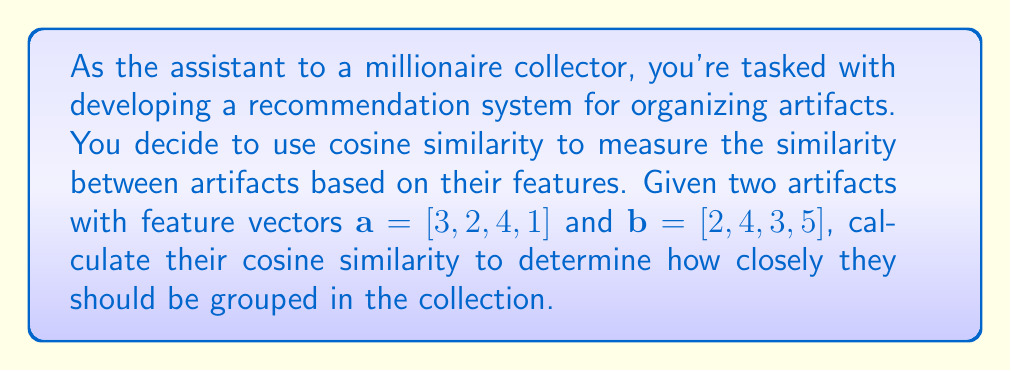Could you help me with this problem? To calculate the cosine similarity between two vectors $\mathbf{a}$ and $\mathbf{b}$, we use the formula:

$$\text{cosine similarity} = \frac{\mathbf{a} \cdot \mathbf{b}}{\|\mathbf{a}\| \|\mathbf{b}\|}$$

Where $\mathbf{a} \cdot \mathbf{b}$ is the dot product of the vectors, and $\|\mathbf{a}\|$ and $\|\mathbf{b}\|$ are the magnitudes (Euclidean norms) of the vectors.

Step 1: Calculate the dot product $\mathbf{a} \cdot \mathbf{b}$
$$\mathbf{a} \cdot \mathbf{b} = (3 \times 2) + (2 \times 4) + (4 \times 3) + (1 \times 5) = 6 + 8 + 12 + 5 = 31$$

Step 2: Calculate the magnitude of $\mathbf{a}$
$$\|\mathbf{a}\| = \sqrt{3^2 + 2^2 + 4^2 + 1^2} = \sqrt{9 + 4 + 16 + 1} = \sqrt{30}$$

Step 3: Calculate the magnitude of $\mathbf{b}$
$$\|\mathbf{b}\| = \sqrt{2^2 + 4^2 + 3^2 + 5^2} = \sqrt{4 + 16 + 9 + 25} = \sqrt{54}$$

Step 4: Apply the cosine similarity formula
$$\text{cosine similarity} = \frac{31}{\sqrt{30} \times \sqrt{54}} = \frac{31}{\sqrt{1620}}$$

Step 5: Simplify the final result
$$\text{cosine similarity} = \frac{31}{\sqrt{1620}} \approx 0.7707$$
Answer: The cosine similarity between the two artifacts is approximately 0.7707. 